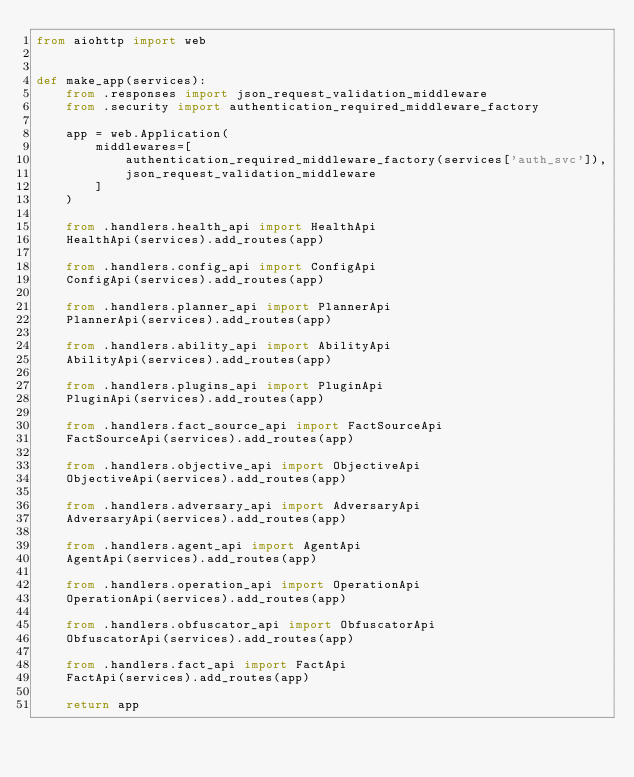<code> <loc_0><loc_0><loc_500><loc_500><_Python_>from aiohttp import web


def make_app(services):
    from .responses import json_request_validation_middleware
    from .security import authentication_required_middleware_factory

    app = web.Application(
        middlewares=[
            authentication_required_middleware_factory(services['auth_svc']),
            json_request_validation_middleware
        ]
    )

    from .handlers.health_api import HealthApi
    HealthApi(services).add_routes(app)

    from .handlers.config_api import ConfigApi
    ConfigApi(services).add_routes(app)

    from .handlers.planner_api import PlannerApi
    PlannerApi(services).add_routes(app)

    from .handlers.ability_api import AbilityApi
    AbilityApi(services).add_routes(app)

    from .handlers.plugins_api import PluginApi
    PluginApi(services).add_routes(app)

    from .handlers.fact_source_api import FactSourceApi
    FactSourceApi(services).add_routes(app)

    from .handlers.objective_api import ObjectiveApi
    ObjectiveApi(services).add_routes(app)

    from .handlers.adversary_api import AdversaryApi
    AdversaryApi(services).add_routes(app)

    from .handlers.agent_api import AgentApi
    AgentApi(services).add_routes(app)

    from .handlers.operation_api import OperationApi
    OperationApi(services).add_routes(app)

    from .handlers.obfuscator_api import ObfuscatorApi
    ObfuscatorApi(services).add_routes(app)

    from .handlers.fact_api import FactApi
    FactApi(services).add_routes(app)

    return app
</code> 